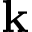Convert formula to latex. <formula><loc_0><loc_0><loc_500><loc_500>k</formula> 